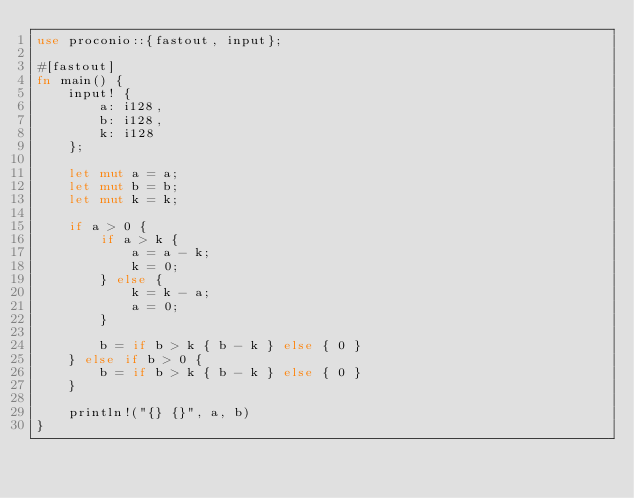<code> <loc_0><loc_0><loc_500><loc_500><_Rust_>use proconio::{fastout, input};

#[fastout]
fn main() {
    input! {
        a: i128,
        b: i128,
        k: i128
    };

    let mut a = a;
    let mut b = b;
    let mut k = k;

    if a > 0 {
        if a > k {
            a = a - k;
            k = 0;
        } else {
            k = k - a;
            a = 0;
        }

        b = if b > k { b - k } else { 0 }
    } else if b > 0 {
        b = if b > k { b - k } else { 0 }
    }

    println!("{} {}", a, b)
}
</code> 